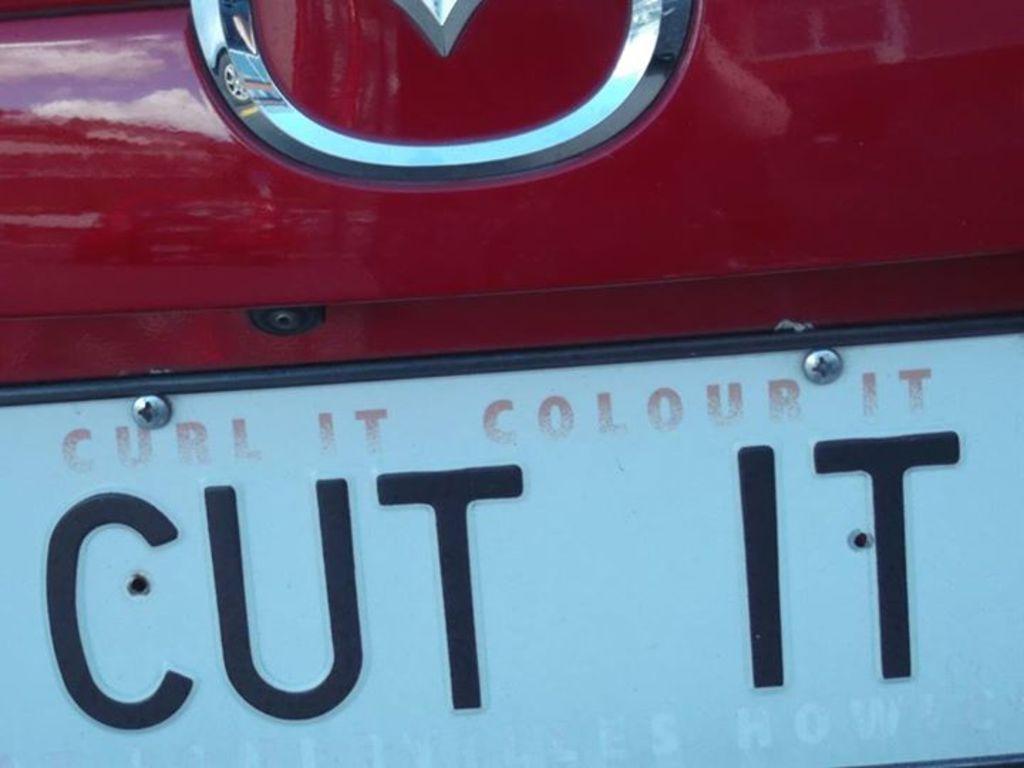What is on the license plate?
Offer a terse response. Cut it. Colour it, cut it and what else?
Make the answer very short. Curl it. 